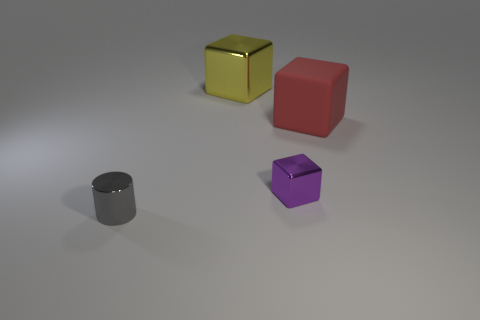Can you describe the lighting and shadows in the image? The lighting in the image appears to be soft and diffused, coming from a direction that is not directly visible in the frame, likely from above. It casts gentle, somewhat elongated shadows to the right of each object, suggesting the light source is to the upper left of the scene. The shadows are subtle and help provide a sense of depth to the image, enhancing the three-dimensional quality of the objects. The softness of the shadows indicates that the light source is not excessively harsh or bright. 